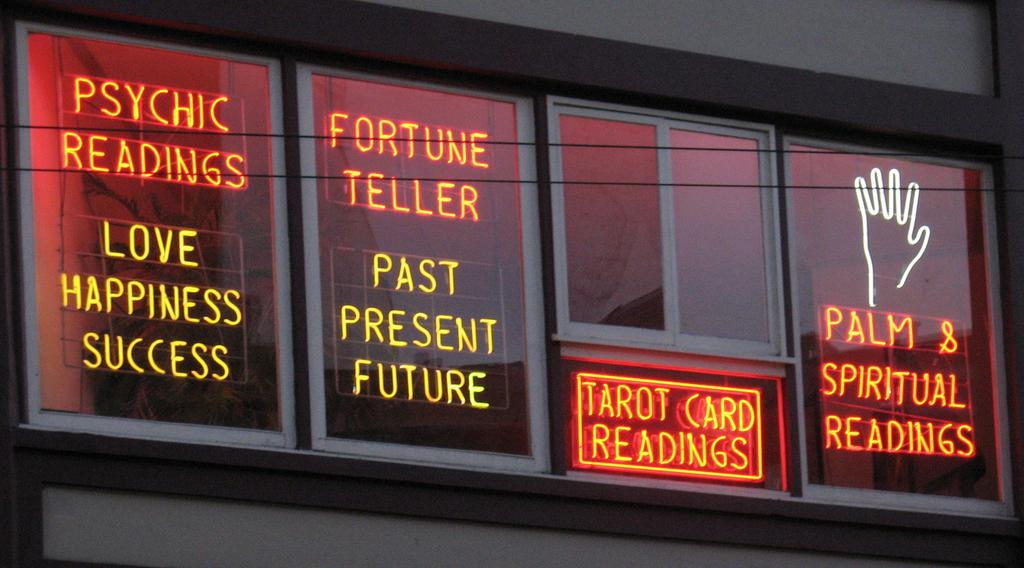<image>
Summarize the visual content of the image. An led sign offering Psychic Readings and Fortune telling. 